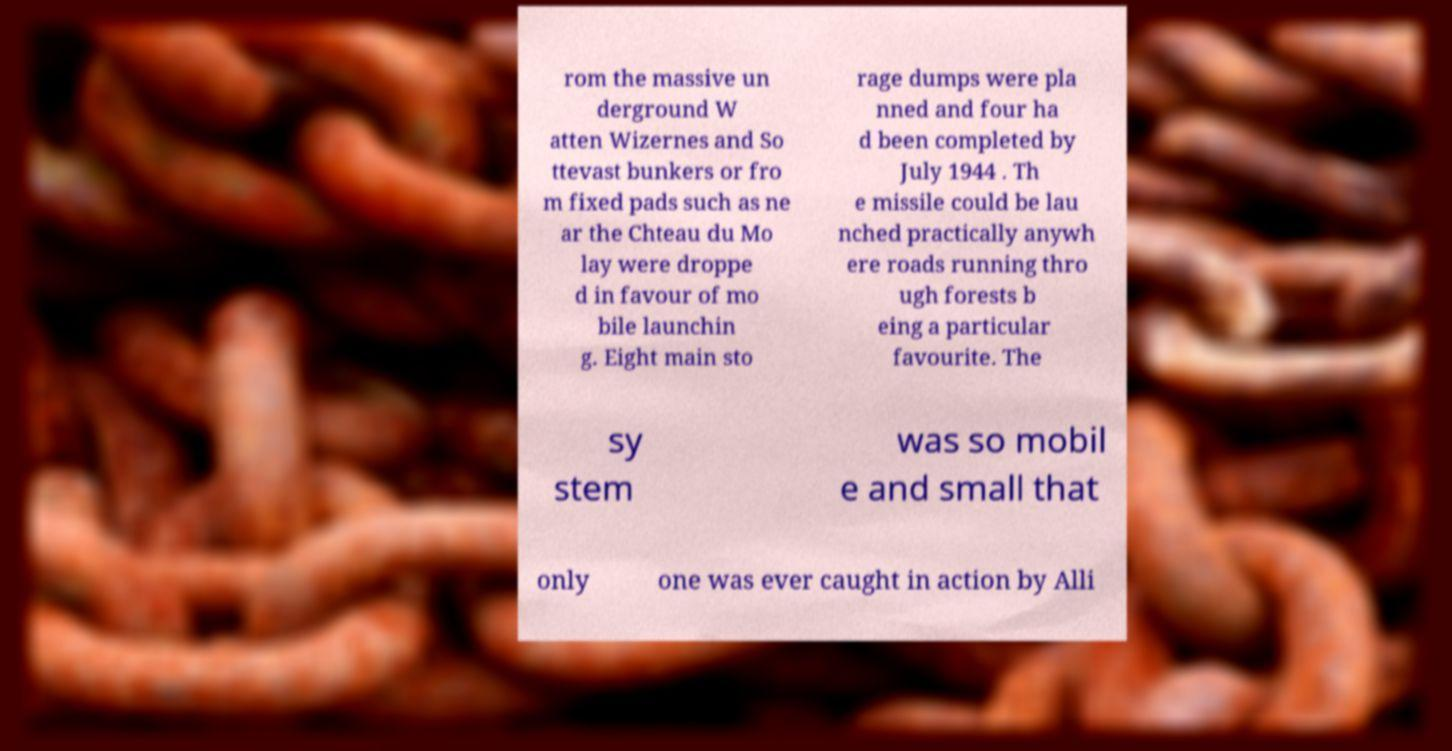Please identify and transcribe the text found in this image. rom the massive un derground W atten Wizernes and So ttevast bunkers or fro m fixed pads such as ne ar the Chteau du Mo lay were droppe d in favour of mo bile launchin g. Eight main sto rage dumps were pla nned and four ha d been completed by July 1944 . Th e missile could be lau nched practically anywh ere roads running thro ugh forests b eing a particular favourite. The sy stem was so mobil e and small that only one was ever caught in action by Alli 